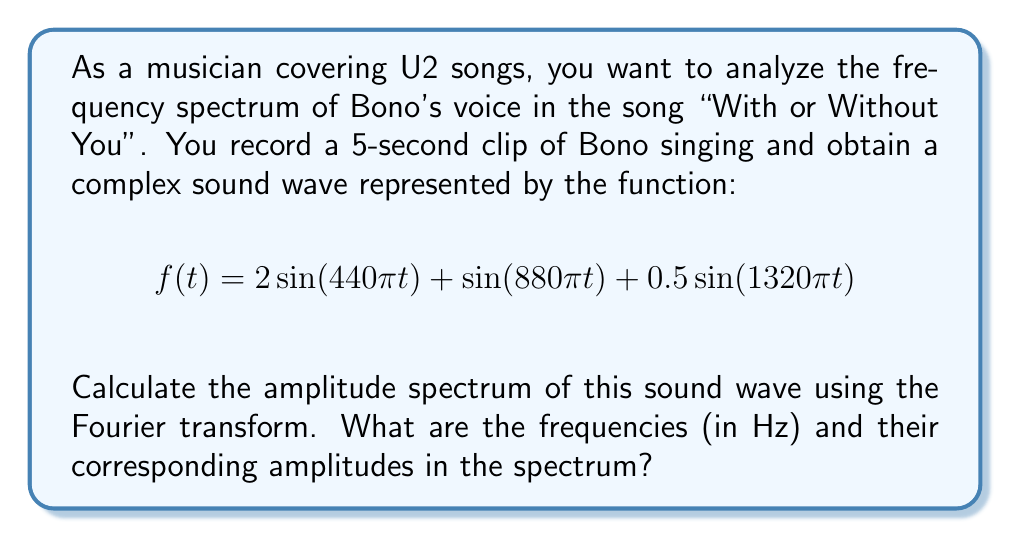Can you solve this math problem? To calculate the frequency spectrum using the Fourier transform, we follow these steps:

1) The Fourier transform of a continuous-time signal $f(t)$ is given by:

   $$F(\omega) = \int_{-\infty}^{\infty} f(t) e^{-i\omega t} dt$$

2) For our signal $f(t) = 2\sin(440\pi t) + \sin(880\pi t) + 0.5\sin(1320\pi t)$, we can use the linearity property of Fourier transforms:

   $$F(\omega) = 2\mathcal{F}\{\sin(440\pi t)\} + \mathcal{F}\{\sin(880\pi t)\} + 0.5\mathcal{F}\{\sin(1320\pi t)\}$$

3) We know that the Fourier transform of $\sin(\omega_0 t)$ is:

   $$\mathcal{F}\{\sin(\omega_0 t)\} = \frac{i}{2}[\delta(\omega + \omega_0) - \delta(\omega - \omega_0)]$$

   where $\delta$ is the Dirac delta function.

4) Applying this to our three sine components:

   $$F(\omega) = 2 \cdot \frac{i}{2}[\delta(\omega + 440\pi) - \delta(\omega - 440\pi)] + \frac{i}{2}[\delta(\omega + 880\pi) - \delta(\omega - 880\pi)] + 0.5 \cdot \frac{i}{2}[\delta(\omega + 1320\pi) - \delta(\omega - 1320\pi)]$$

5) The amplitude spectrum is given by $|F(\omega)|$. The magnitude of the delta functions gives us the amplitudes, and their locations give us the frequencies.

6) Converting angular frequency $\omega$ to Hz $(f = \omega / 2\pi)$, we get:

   - 220 Hz with amplitude 2
   - 440 Hz with amplitude 1
   - 660 Hz with amplitude 0.5

Note: The negative frequencies have the same amplitudes but are typically ignored in audio analysis.
Answer: 220 Hz (2), 440 Hz (1), 660 Hz (0.5) 